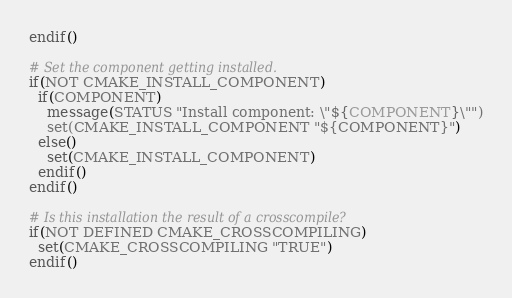<code> <loc_0><loc_0><loc_500><loc_500><_CMake_>endif()

# Set the component getting installed.
if(NOT CMAKE_INSTALL_COMPONENT)
  if(COMPONENT)
    message(STATUS "Install component: \"${COMPONENT}\"")
    set(CMAKE_INSTALL_COMPONENT "${COMPONENT}")
  else()
    set(CMAKE_INSTALL_COMPONENT)
  endif()
endif()

# Is this installation the result of a crosscompile?
if(NOT DEFINED CMAKE_CROSSCOMPILING)
  set(CMAKE_CROSSCOMPILING "TRUE")
endif()

</code> 